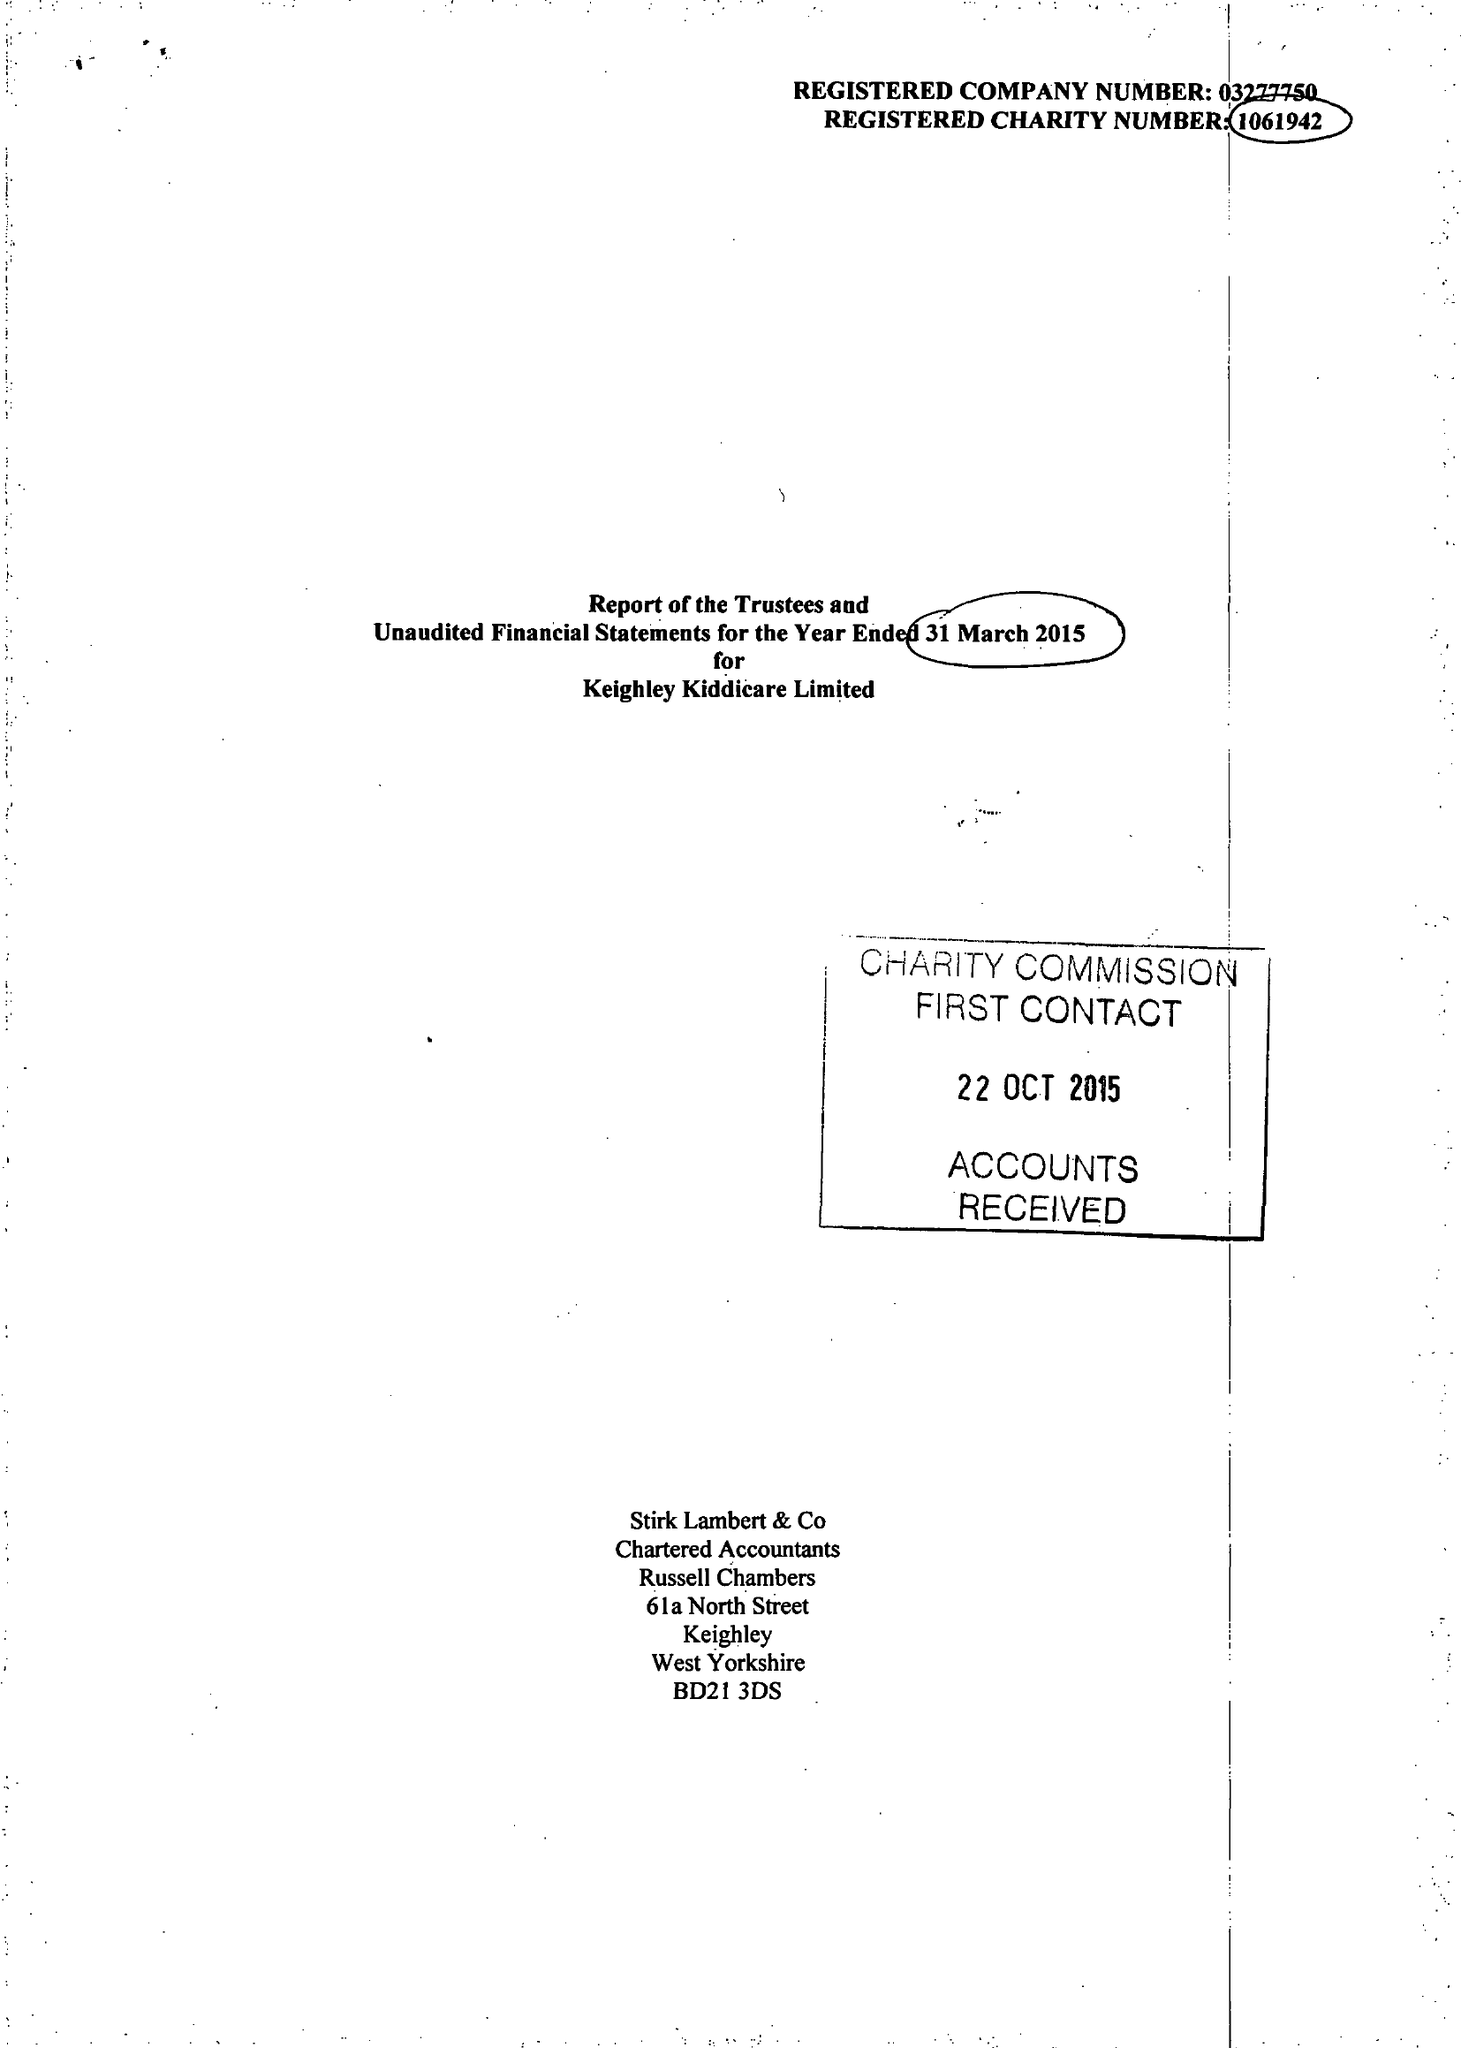What is the value for the address__postcode?
Answer the question using a single word or phrase. BD22 0QG 